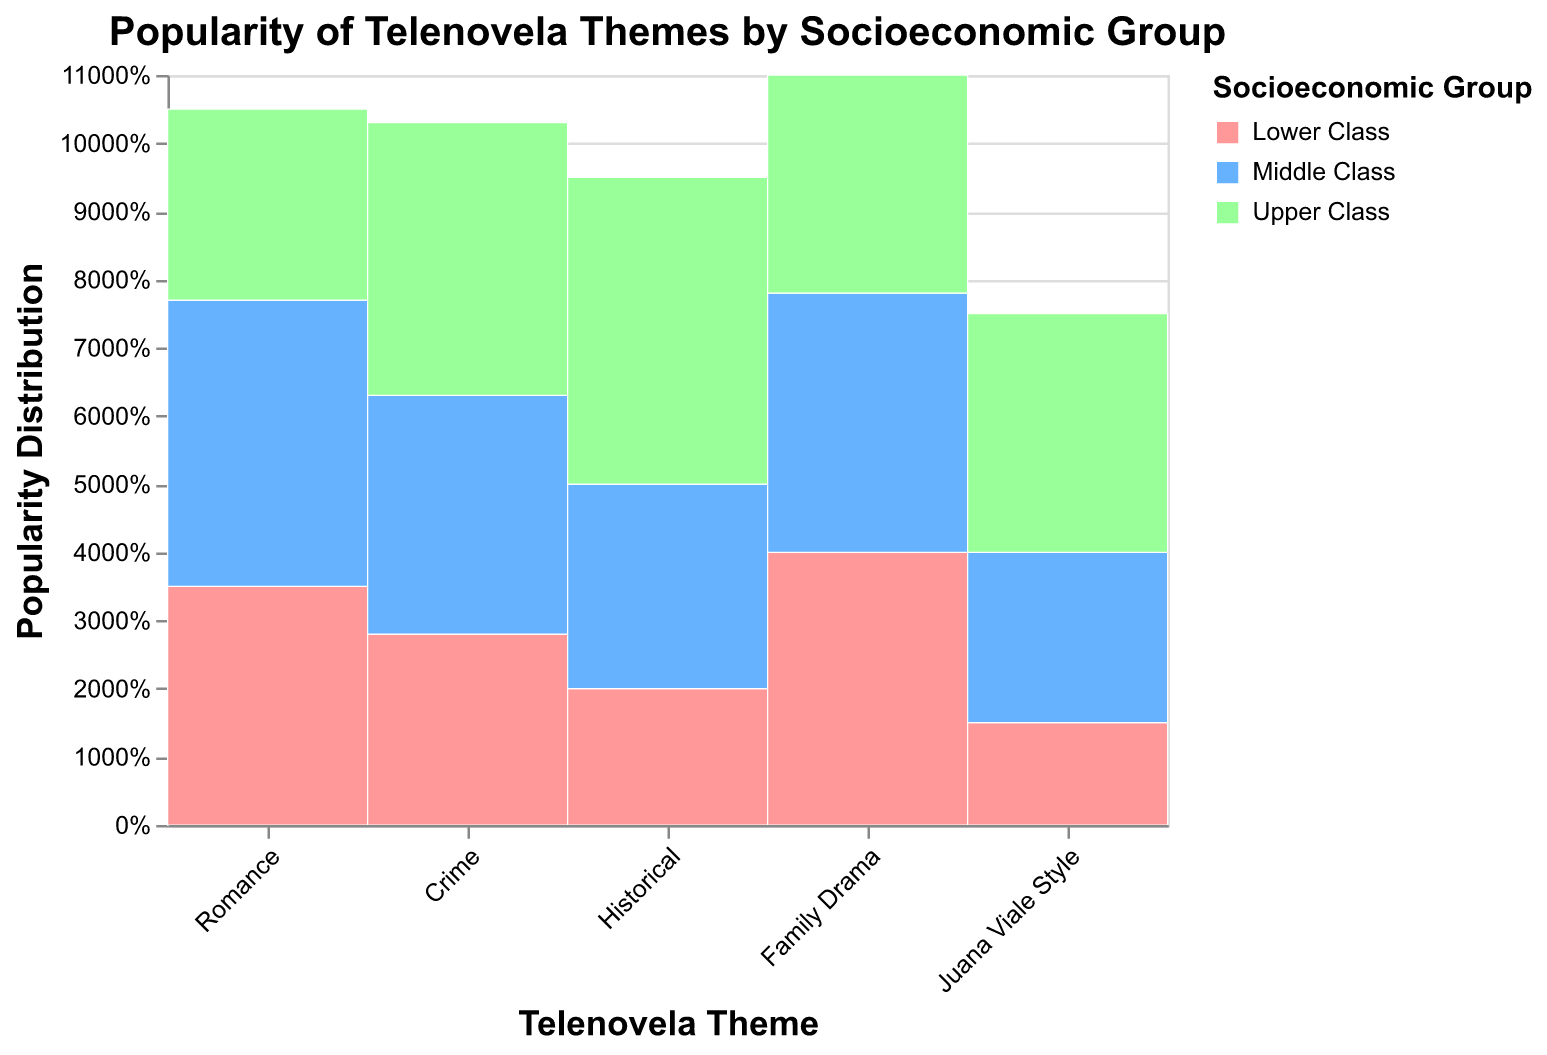Which telenovela theme is the most popular among the Upper Class? The plot shows percentages of each theme's popularity distributed among socioeconomic groups. For the Upper Class, we look for the largest segment in the 'Upper Class' section. The Historical theme has the highest percentage in the Upper Class.
Answer: Historical What socioeconomic group has the highest preference for Family Drama? In the plot, check the segments for Family Drama by socioeconomic group. The one with the highest percentage for Family Drama is the Lower Class.
Answer: Lower Class What percentage of the Middle Class prefers the Juana Viale Style theme? Locate the Juana Viale Style theme and look at the Middle Class segment. The tooltip should indicate the percentage, which is 25%.
Answer: 25% Compare the popularity of Crime themes between the Lower Class and Upper Class. Which is higher? Analyze the segments for the Crime theme in the Lower Class and Upper Class. The Upper Class has a larger segment, indicating higher popularity.
Answer: Upper Class Which socioeconomic group shows a balanced interest in the Romance theme? Examine the Romance theme's segments across all socioeconomic classes. The segments for the Middle Class and Lower Class are relatively close, but the Middle Class segment is the most balanced.
Answer: Middle Class Is the Historical theme more popular among the Middle Class or the Lower Class? Compare the segments for the Historical theme between the Middle Class and Lower Class. The Middle Class has a larger segment for the Historical theme.
Answer: Middle Class Which theme is least popular among the Lower Class? Identify the theme with the smallest segment in the Lower Class’s section. The Juana Viale Style theme has the smallest segment here.
Answer: Juana Viale Style How does the popularity of Romance themes compare between the Upper Class and Lower Class? Look at the segments for Romance themes in the Upper Class and Lower Class. The Lower Class has a larger segment, indicating higher popularity among them.
Answer: Lower Class Which socioeconomic group prefers Historical themes the most? Compare the segments for Historical themes across socioeconomic groups. The Upper Class has the largest segment, indicating the highest preference.
Answer: Upper Class Are Family Drama themes more popular among the Middle Class or Upper Class? Analyze the segments for Family Drama themes between the Middle Class and Upper Class. The Middle Class has a larger segment, showing greater popularity.
Answer: Middle Class 